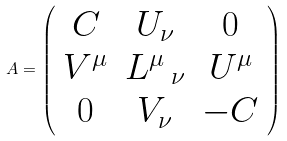<formula> <loc_0><loc_0><loc_500><loc_500>A = \left ( \begin{array} { c c c } C & U _ { \nu } & 0 \\ V ^ { \mu } & L ^ { \mu } \, _ { \nu } & U ^ { \mu } \\ 0 & V _ { \nu } & - C \end{array} \right )</formula> 